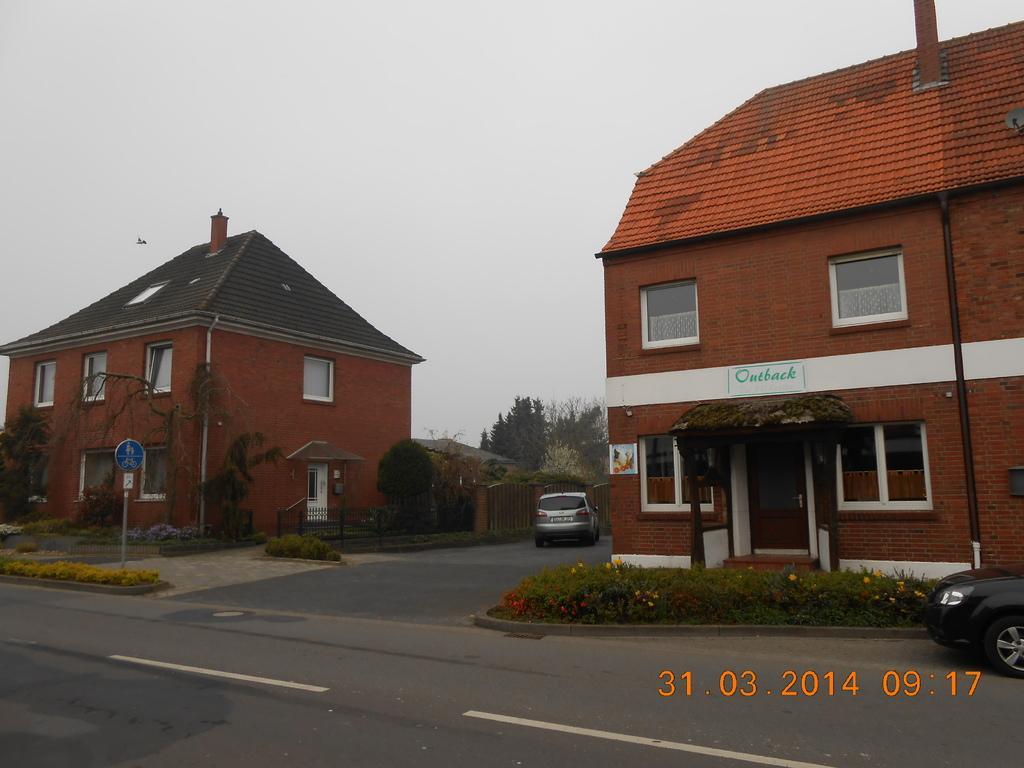Can you describe this image briefly? This picture is clicked outside. On the right there is a house with a red roof top and we can see the door and windows of the house. On the right corner there is a black color car and we can see the pole and plants. In the center there is a car running on the ground and there is a board attached to the pole and we can see the grass, house, trees and some other objects. In the background there is sky and the trees. At the bottom right corner there is a watermark on the image. 